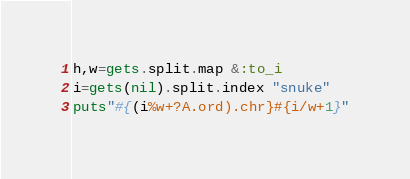<code> <loc_0><loc_0><loc_500><loc_500><_Ruby_>h,w=gets.split.map &:to_i
i=gets(nil).split.index "snuke"
puts"#{(i%w+?A.ord).chr}#{i/w+1}"</code> 